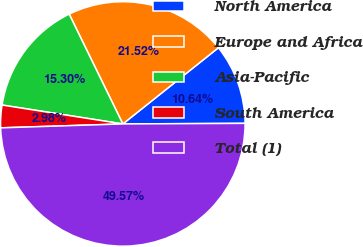Convert chart to OTSL. <chart><loc_0><loc_0><loc_500><loc_500><pie_chart><fcel>North America<fcel>Europe and Africa<fcel>Asia-Pacific<fcel>South America<fcel>Total (1)<nl><fcel>10.64%<fcel>21.52%<fcel>15.3%<fcel>2.98%<fcel>49.57%<nl></chart> 